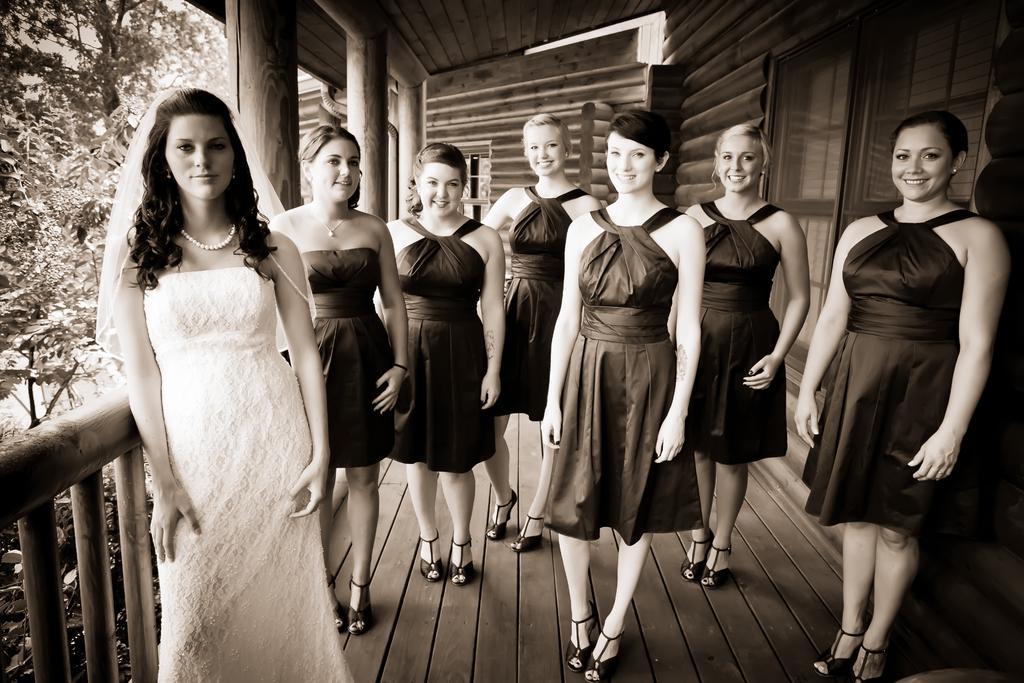Could you give a brief overview of what you see in this image? In the foreground I can see seven women's are standing on the floor and fence. In the background I can see a door, pillars, trees and a rooftop. This image is taken during a day. 